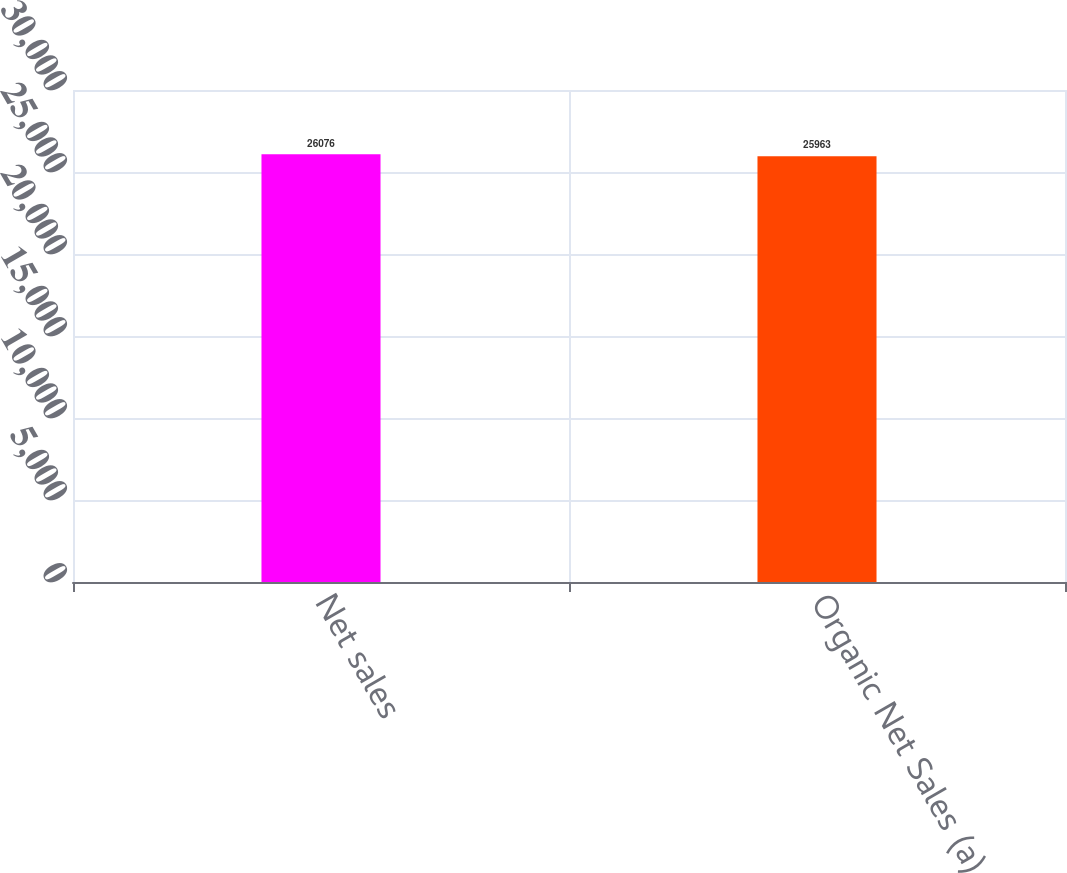Convert chart to OTSL. <chart><loc_0><loc_0><loc_500><loc_500><bar_chart><fcel>Net sales<fcel>Organic Net Sales (a)<nl><fcel>26076<fcel>25963<nl></chart> 